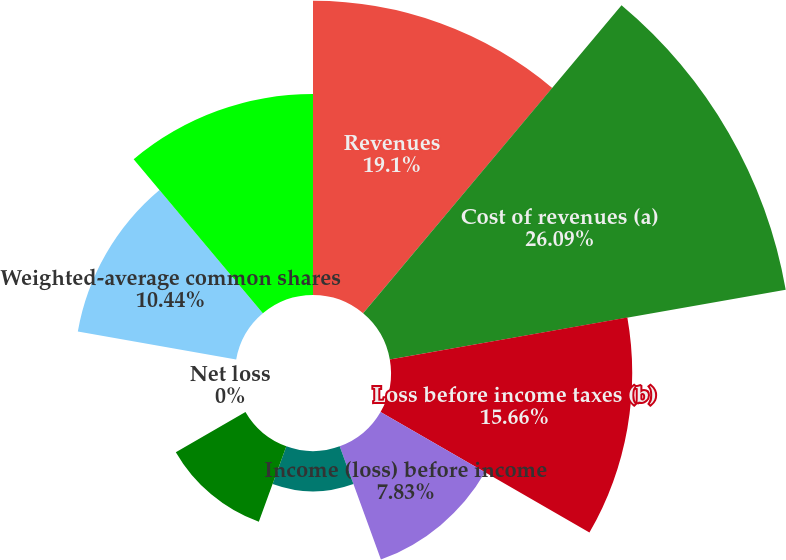Convert chart to OTSL. <chart><loc_0><loc_0><loc_500><loc_500><pie_chart><fcel>Revenues<fcel>Cost of revenues (a)<fcel>Loss before income taxes (b)<fcel>Income (loss) before income<fcel>Loss before income taxes<fcel>Income taxes (benefit)<fcel>Net loss<fcel>Weighted-average common shares<fcel>Adjusted weighted-average<nl><fcel>19.1%<fcel>26.1%<fcel>15.66%<fcel>7.83%<fcel>2.61%<fcel>5.22%<fcel>0.0%<fcel>10.44%<fcel>13.05%<nl></chart> 